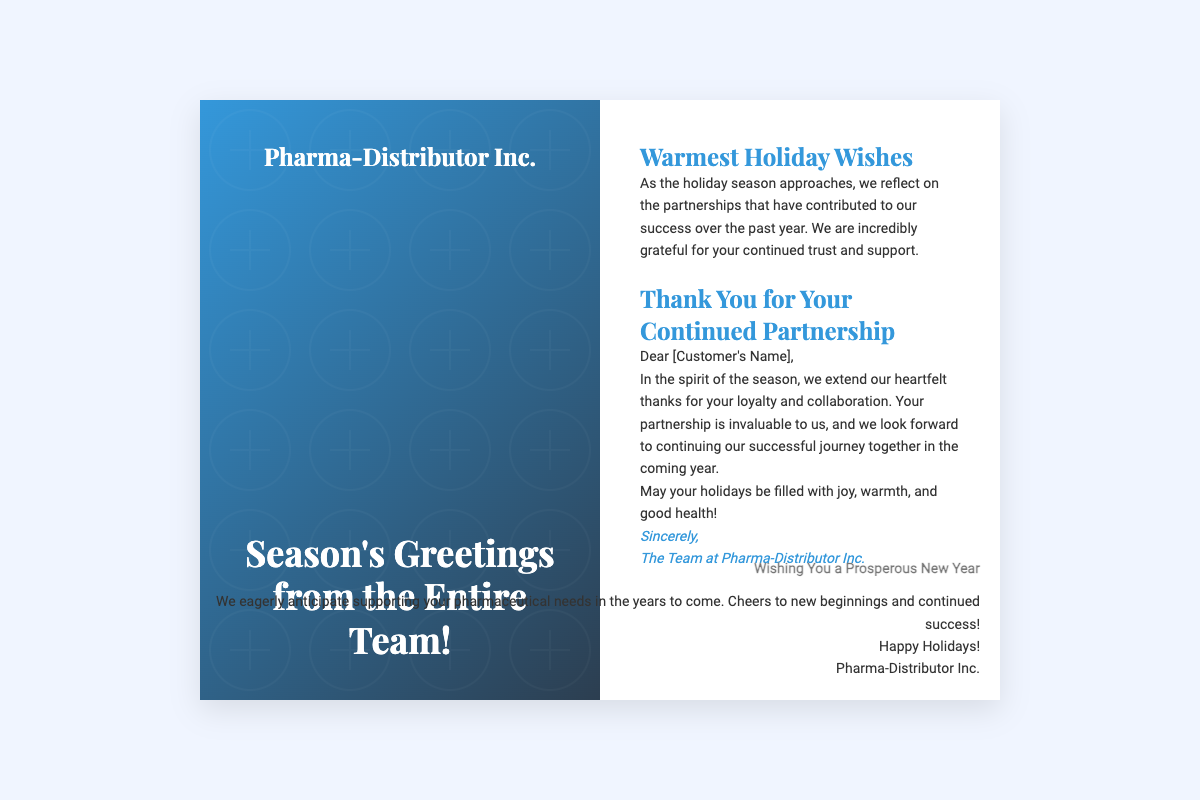What is the name of the company sending the greeting card? The company sending the greeting card is mentioned in the logo area of the front cover.
Answer: Pharma-Distributor Inc What is the main theme of the greeting card? The greeting card expresses gratitude and holiday wishes.
Answer: Holiday Wishes Who is the greeting card addressed to? The card contains a personalized message that indicates a specific recipient.
Answer: [Customer's Name] What does the card wish for the recipient's holidays? The card contains a specific wish for the recipient's holiday experience.
Answer: joy, warmth, and good health Which season is being celebrated in the card? The card explicitly refers to a specific time of year in its greeting.
Answer: Holiday season What phrase is used to express thanks for partnership? A specific phrase within the card conveys appreciation for the recipient’s collaboration.
Answer: Thank You for Your Continued Partnership Which team is represented in the greeting card? The card mentions the group that extends the warm greetings and thanks.
Answer: The Team at Pharma-Distributor Inc What does the back cover wish for the New Year? The back cover has a specific phrase related to the upcoming year's sentiment.
Answer: A Prosperous New Year What is the predominant color scheme on the front cover? The front cover features a combination of colors that create a specific visual impact.
Answer: Blue and Dark Blue 